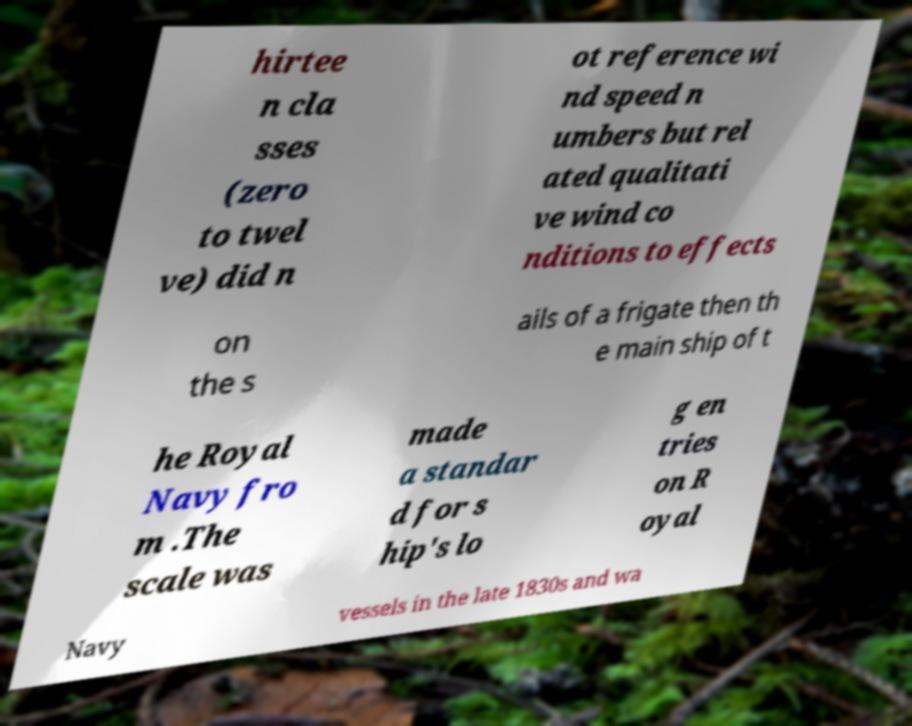Can you read and provide the text displayed in the image?This photo seems to have some interesting text. Can you extract and type it out for me? hirtee n cla sses (zero to twel ve) did n ot reference wi nd speed n umbers but rel ated qualitati ve wind co nditions to effects on the s ails of a frigate then th e main ship of t he Royal Navy fro m .The scale was made a standar d for s hip's lo g en tries on R oyal Navy vessels in the late 1830s and wa 